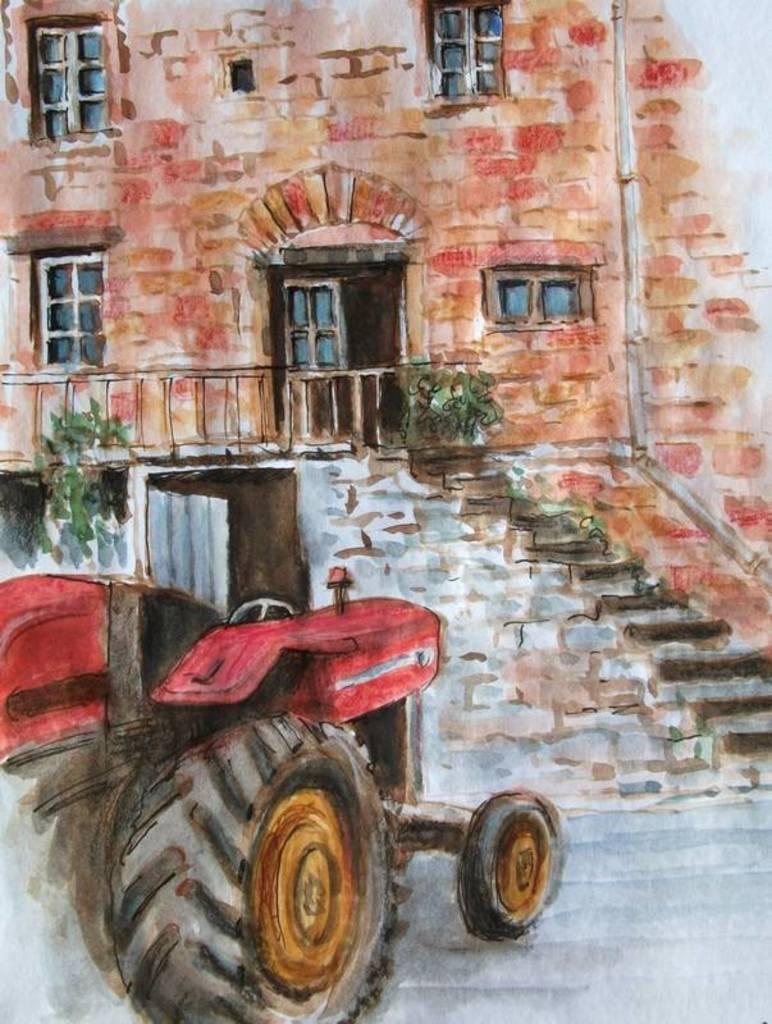How would you summarize this image in a sentence or two? In the picture I can see the painting. I can see the painting of a tractor on the bottom left side. I can see the building and windows. I can see the staircase and the fence of the building. 